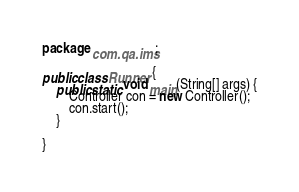<code> <loc_0><loc_0><loc_500><loc_500><_Java_>package com.qa.ims;

public class Runner {
	public static void main(String[] args) {
		Controller con = new Controller();
		con.start();
	}

}
</code> 